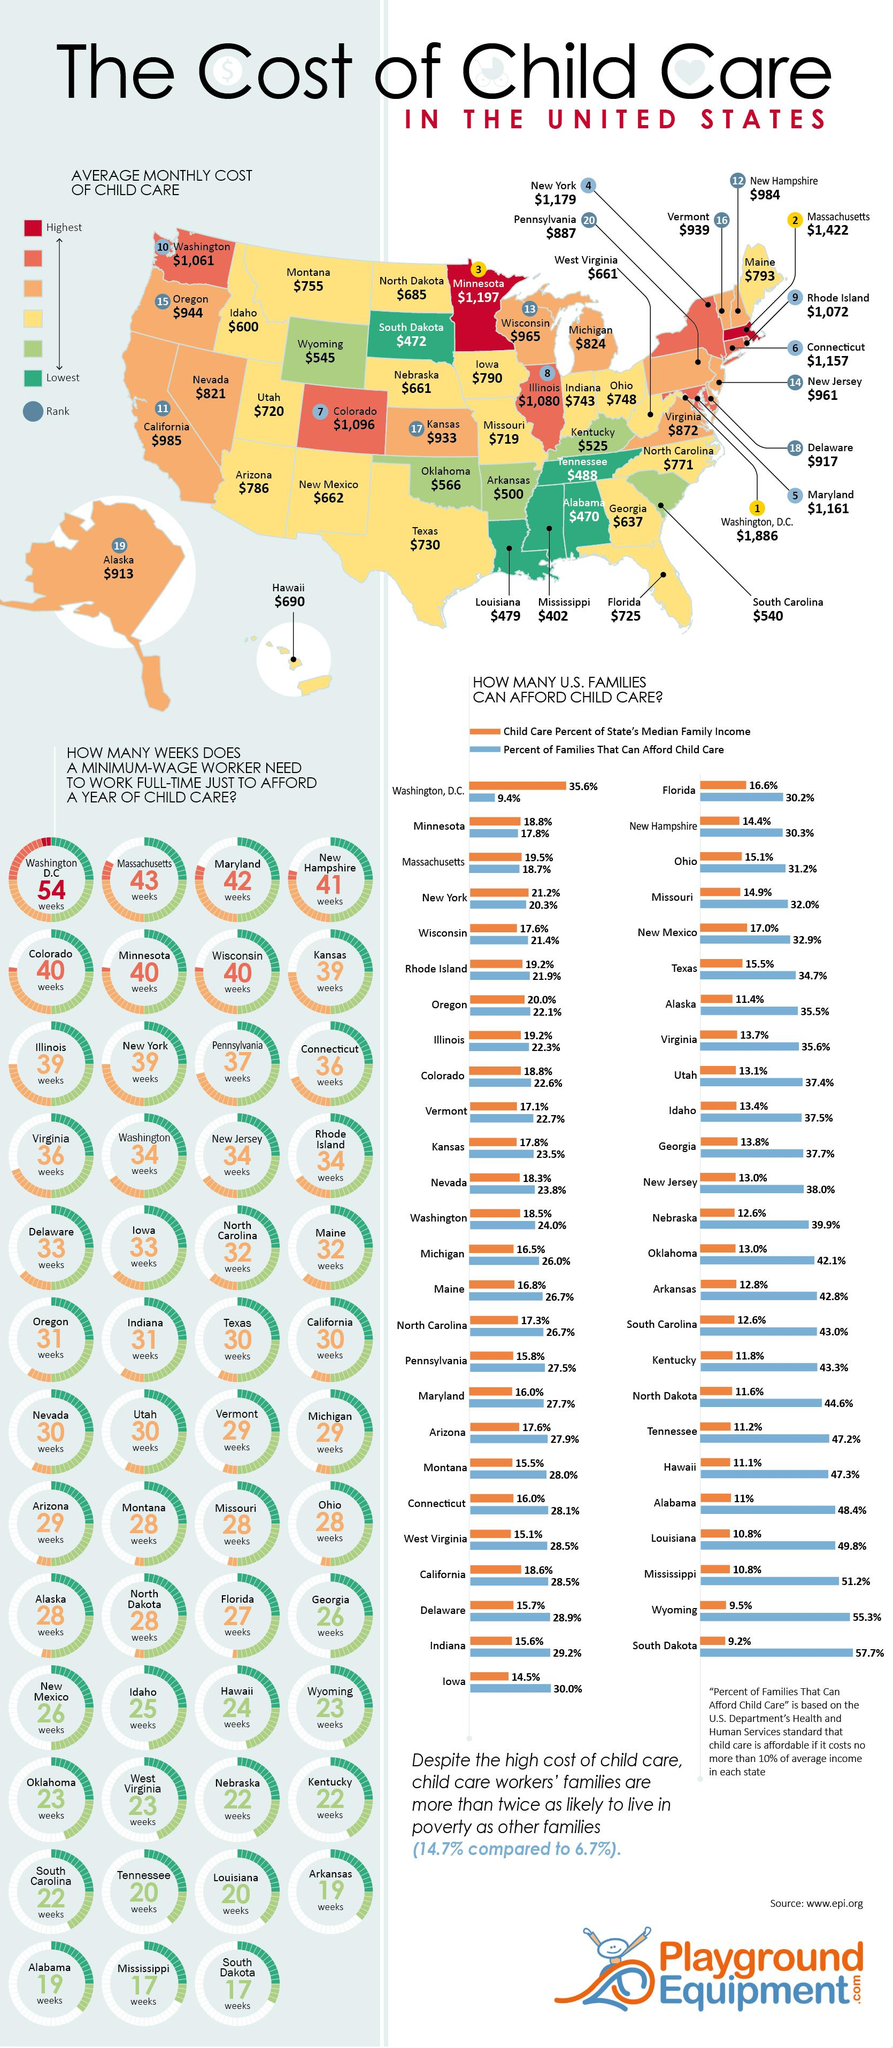Outline some significant characteristics in this image. In Michigan and Nevada, the percent of families that can afford child care is 2.2%. The combined percentage of families that can afford child care in Ohio and Florida is 1%. According to statistics, two states have the highest average monthly cost of child care. The second-lowest average monthly cost of child care can be found in 5 states. According to my research, the five states with the lowest average monthly cost of child care are: [list the states in order of lowest to highest cost] 